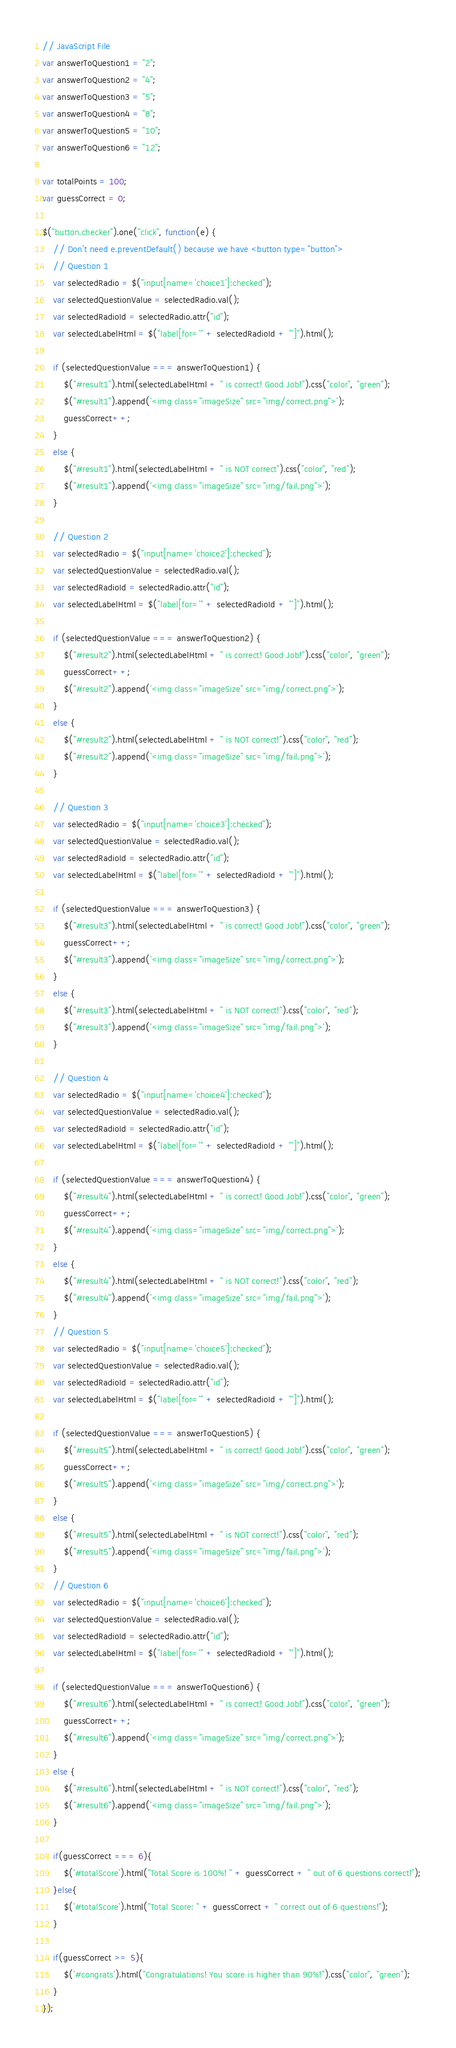<code> <loc_0><loc_0><loc_500><loc_500><_JavaScript_>// JavaScript File
var answerToQuestion1 = "2";
var answerToQuestion2 = "4";
var answerToQuestion3 = "5";
var answerToQuestion4 = "8";
var answerToQuestion5 = "10";
var answerToQuestion6 = "12";

var totalPoints = 100;
var guessCorrect = 0; 

$("button.checker").one("click", function(e) {
    // Don't need e.preventDefault() because we have <button type="button">
    // Question 1 
    var selectedRadio = $("input[name='choice1']:checked");
    var selectedQuestionValue = selectedRadio.val();
    var selectedRadioId = selectedRadio.attr("id");
    var selectedLabelHtml = $("label[for='" + selectedRadioId + "']").html();

    if (selectedQuestionValue === answerToQuestion1) {
        $("#result1").html(selectedLabelHtml + " is correct! Good Job!").css("color", "green");
        $("#result1").append('<img class="imageSize" src="img/correct.png">');
        guessCorrect++;
    }
    else {
        $("#result1").html(selectedLabelHtml + " is NOT correct").css("color", "red");
        $("#result1").append('<img class="imageSize" src="img/fail.png">');
    }

    // Question 2
    var selectedRadio = $("input[name='choice2']:checked");
    var selectedQuestionValue = selectedRadio.val();
    var selectedRadioId = selectedRadio.attr("id");
    var selectedLabelHtml = $("label[for='" + selectedRadioId + "']").html();

    if (selectedQuestionValue === answerToQuestion2) {
        $("#result2").html(selectedLabelHtml + " is correct! Good Job!").css("color", "green");
        guessCorrect++;
        $("#result2").append('<img class="imageSize" src="img/correct.png">');
    }
    else {
        $("#result2").html(selectedLabelHtml + " is NOT correct!").css("color", "red");
        $("#result2").append('<img class="imageSize" src="img/fail.png">');
    }
    
    // Question 3
    var selectedRadio = $("input[name='choice3']:checked");
    var selectedQuestionValue = selectedRadio.val();
    var selectedRadioId = selectedRadio.attr("id");
    var selectedLabelHtml = $("label[for='" + selectedRadioId + "']").html();

    if (selectedQuestionValue === answerToQuestion3) {
        $("#result3").html(selectedLabelHtml + " is correct! Good Job!").css("color", "green");
        guessCorrect++;
        $("#result3").append('<img class="imageSize" src="img/correct.png">');
    }
    else {
        $("#result3").html(selectedLabelHtml + " is NOT correct!").css("color", "red");
        $("#result3").append('<img class="imageSize" src="img/fail.png">');
    }
    
    // Question 4
    var selectedRadio = $("input[name='choice4']:checked");
    var selectedQuestionValue = selectedRadio.val();
    var selectedRadioId = selectedRadio.attr("id");
    var selectedLabelHtml = $("label[for='" + selectedRadioId + "']").html();

    if (selectedQuestionValue === answerToQuestion4) {
        $("#result4").html(selectedLabelHtml + " is correct! Good Job!").css("color", "green");
        guessCorrect++;
        $("#result4").append('<img class="imageSize" src="img/correct.png">');
    }
    else {
        $("#result4").html(selectedLabelHtml + " is NOT correct!").css("color", "red");
        $("#result4").append('<img class="imageSize" src="img/fail.png">');
    }
    // Question 5
    var selectedRadio = $("input[name='choice5']:checked");
    var selectedQuestionValue = selectedRadio.val();
    var selectedRadioId = selectedRadio.attr("id");
    var selectedLabelHtml = $("label[for='" + selectedRadioId + "']").html();

    if (selectedQuestionValue === answerToQuestion5) {
        $("#result5").html(selectedLabelHtml + " is correct! Good Job!").css("color", "green");
        guessCorrect++;
        $("#result5").append('<img class="imageSize" src="img/correct.png">');
    }
    else {
        $("#result5").html(selectedLabelHtml + " is NOT correct!").css("color", "red");
        $("#result5").append('<img class="imageSize" src="img/fail.png">');
    }
    // Question 6
    var selectedRadio = $("input[name='choice6']:checked");
    var selectedQuestionValue = selectedRadio.val();
    var selectedRadioId = selectedRadio.attr("id");
    var selectedLabelHtml = $("label[for='" + selectedRadioId + "']").html();

    if (selectedQuestionValue === answerToQuestion6) {
        $("#result6").html(selectedLabelHtml + " is correct! Good Job!").css("color", "green");
        guessCorrect++;
        $("#result6").append('<img class="imageSize" src="img/correct.png">');
    }
    else {
        $("#result6").html(selectedLabelHtml + " is NOT correct!").css("color", "red");
        $("#result6").append('<img class="imageSize" src="img/fail.png">');
    }
    
    if(guessCorrect === 6){
        $('#totalScore').html("Total Score is 100%! " + guessCorrect + " out of 6 questions correct!");
    }else{
        $('#totalScore').html("Total Score: " + guessCorrect + " correct out of 6 questions!");
    }
    
    if(guessCorrect >= 5){
        $('#congrats').html("Congratulations! You score is higher than 90%!").css("color", "green");
    }
});
</code> 